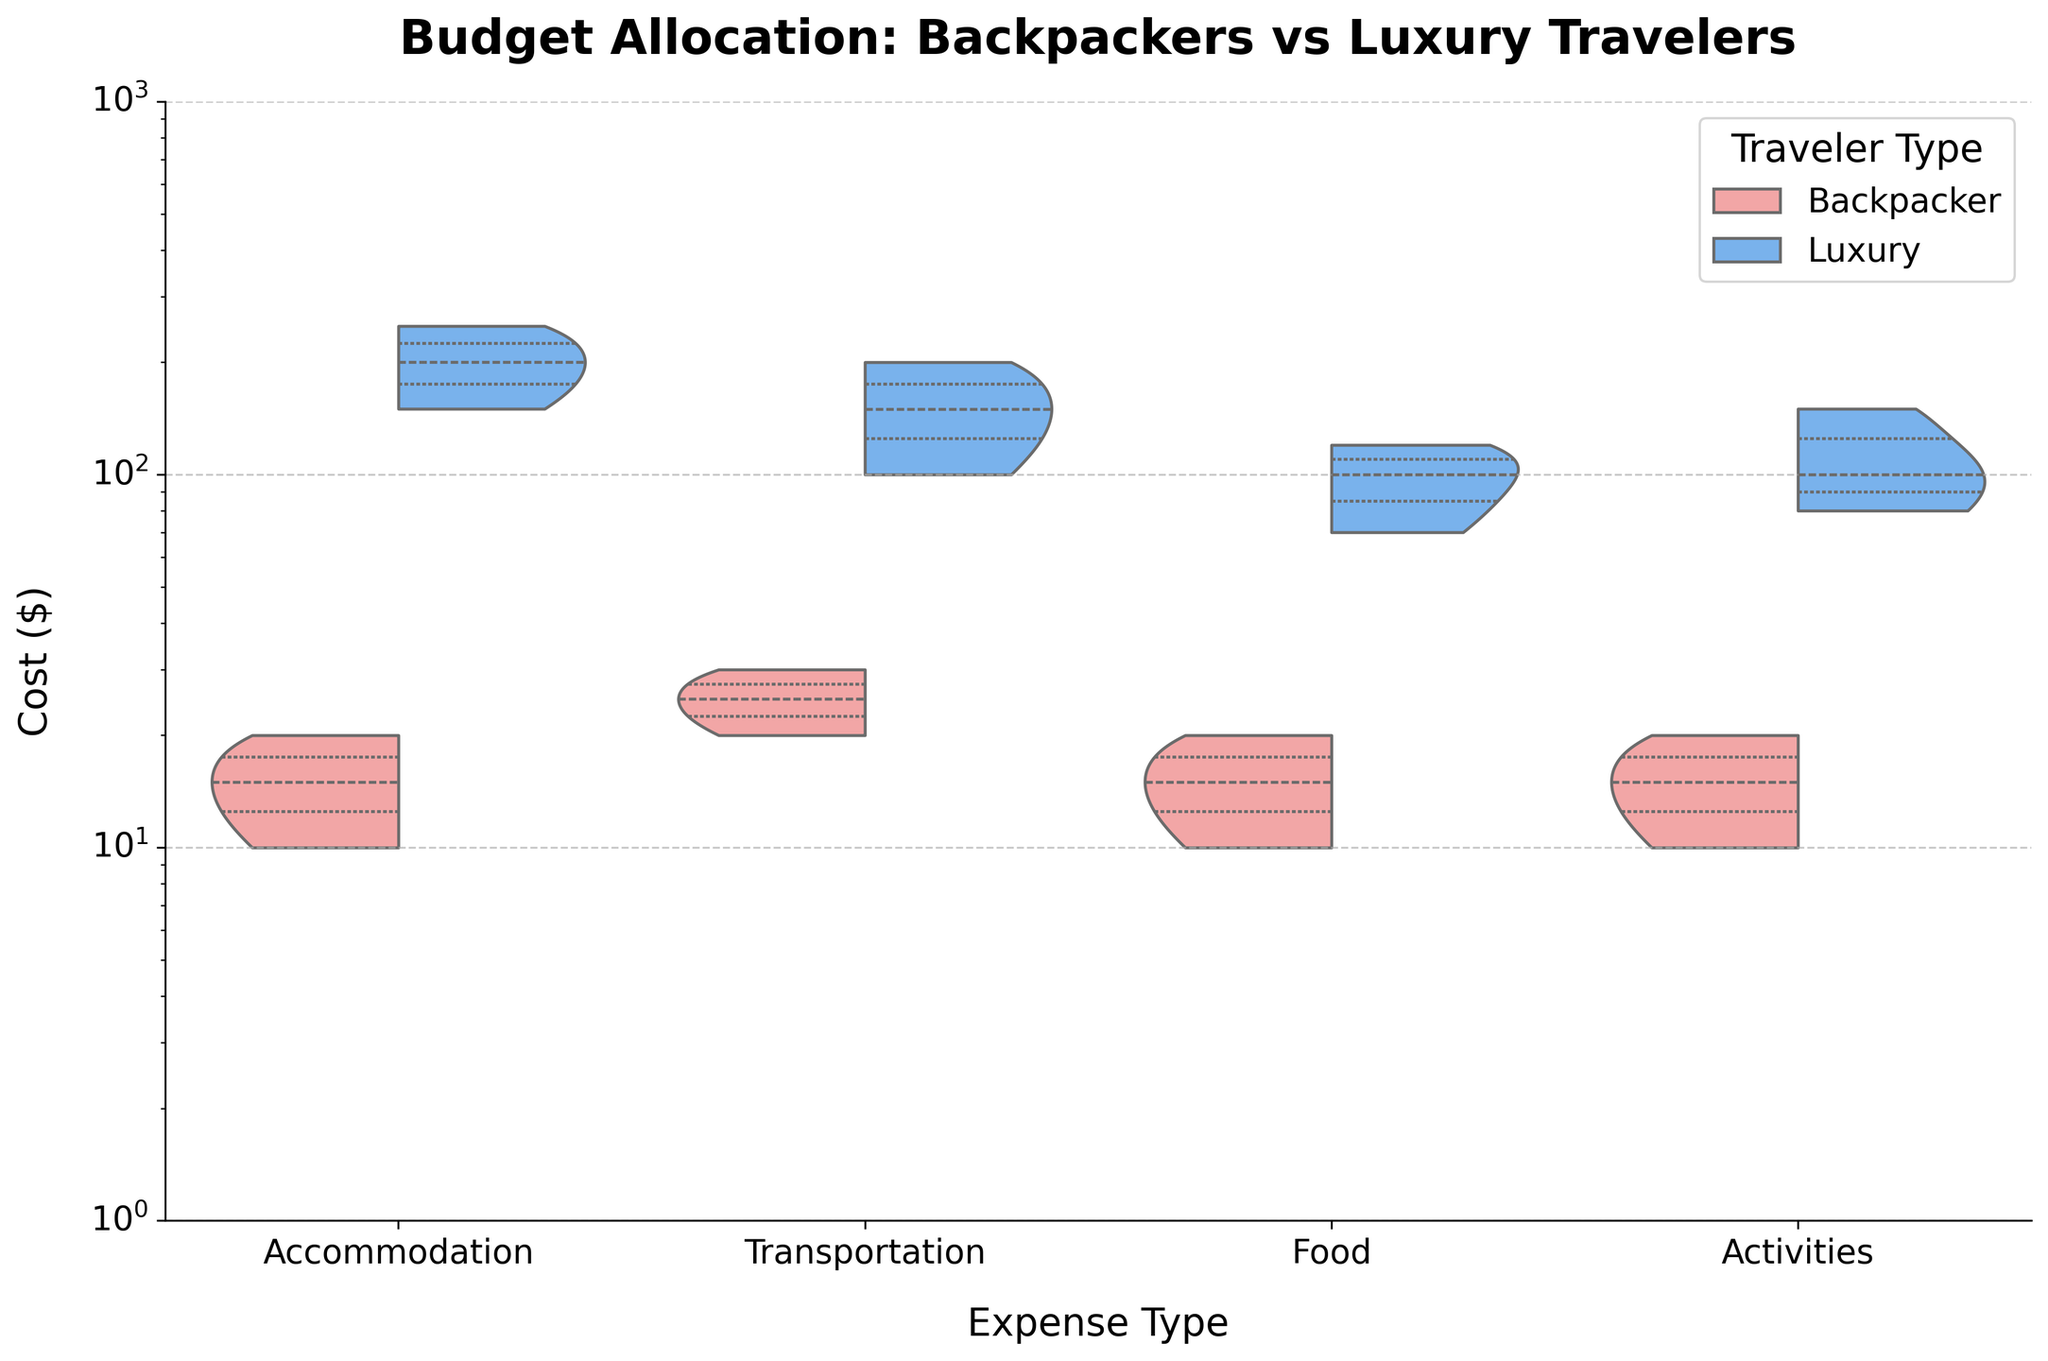what's the title of the chart? The title of the chart is displayed at the top of the figure. It summarizes what the chart is about. The title is "Budget Allocation: Backpackers vs Luxury Travelers".
Answer: Budget Allocation: Backpackers vs Luxury Travelers what type of expense do luxury travelers spend the most on? To find this, look at the different ExpenseType categories (Accommodation, Transportation, Food, Activities) in the chart. For each category, observe the upper end of the violin plot where the Cost values for luxury travelers are represented. The highest observed cost for luxury travelers is in Accommodation.
Answer: Accommodation which traveler type generally spends less on transportation? To determine this, compare the spread of the violin plots for Transportation between Backpackers and Luxury travelers. The Backpacker plot has costs up to around $30 and the Luxury plot goes up to around $200. Thus, Backpackers spend less on transportation comparatively.
Answer: Backpackers what's the lower quartile cost for food for backpackers? In a violin plot, the quartiles can be indicated by lines or the shading within the plot. For backpackers, the food costs have a lower quartile (25th percentile) which appears around the $10 mark on the y-axis.
Answer: $10 how does the median accommodation cost compare between backpackers and luxury travelers? The median is represented by the line in the middle of each violin plot. For accommodation, you compare the middle lines within each plot for Backpackers and Luxury travelers. The median for Backpackers appears to be around $15, whereas for Luxury travelers, it appears to be around $200.
Answer: Luxury travelers' median accommodation cost is much higher than backpackers' what expense type shows the greatest disparity in spending between the two traveler types? Disparity can be viewed by the spread and distance between the two sides of the violin plot for each ExpenseType. The greatest disparity is observed in Accommodation, where the Backpackers’ costs are vastly lower compared to Luxury travelers’ costs.
Answer: Accommodation how do the activity expenses for backpackers compare to those for luxury travelers? For Activities, observe the two sides of the violin plot. Backpackers’ costs range up to around $20, whereas for Luxury travelers, costs can go up to around $150. This shows that Luxury travelers spend significantly more on activities compared to Backpackers.
Answer: Luxury travelers spend more on activities is the cost distribution for transportation wider for backpackers or luxury travelers? The width of the violin plot shows the distribution density. Comparing the two sides of the Transportation plot, the Luxury travelers have a wider and more distributed cost range compared to the narrow and concentrated range for Backpackers.
Answer: Luxury travelers for which expense type do the two traveler types have the most similar spending patterns? This can be determined by observing the overlap and shape similarity between the violin plots for both traveler types. Food shows the most similar spending patterns, with both plots overlapping considerably in the $10-$20 range for Backpackers and $70-$120 for Luxury travelers.
Answer: Food 